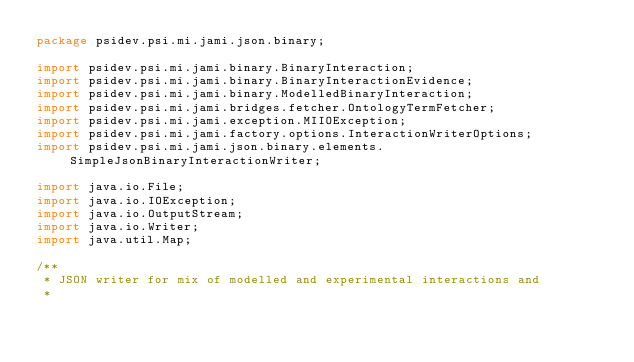<code> <loc_0><loc_0><loc_500><loc_500><_Java_>package psidev.psi.mi.jami.json.binary;

import psidev.psi.mi.jami.binary.BinaryInteraction;
import psidev.psi.mi.jami.binary.BinaryInteractionEvidence;
import psidev.psi.mi.jami.binary.ModelledBinaryInteraction;
import psidev.psi.mi.jami.bridges.fetcher.OntologyTermFetcher;
import psidev.psi.mi.jami.exception.MIIOException;
import psidev.psi.mi.jami.factory.options.InteractionWriterOptions;
import psidev.psi.mi.jami.json.binary.elements.SimpleJsonBinaryInteractionWriter;

import java.io.File;
import java.io.IOException;
import java.io.OutputStream;
import java.io.Writer;
import java.util.Map;

/**
 * JSON writer for mix of modelled and experimental interactions and
 *</code> 